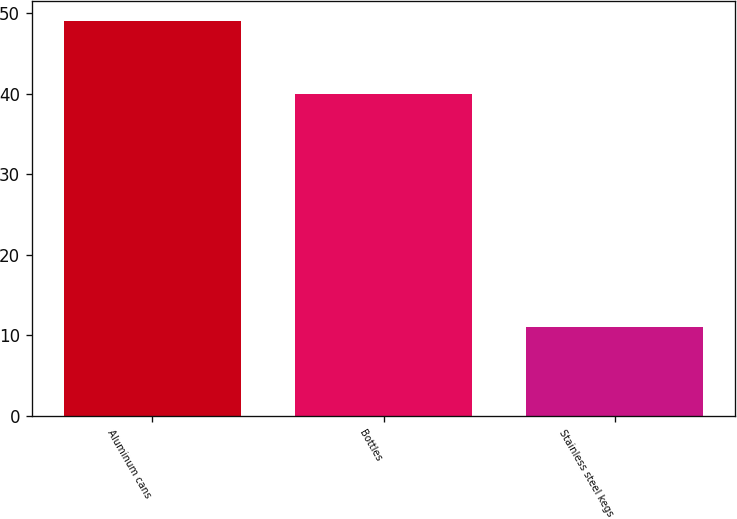Convert chart. <chart><loc_0><loc_0><loc_500><loc_500><bar_chart><fcel>Aluminum cans<fcel>Bottles<fcel>Stainless steel kegs<nl><fcel>49<fcel>40<fcel>11<nl></chart> 